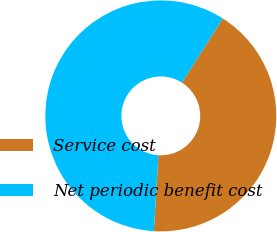Convert chart to OTSL. <chart><loc_0><loc_0><loc_500><loc_500><pie_chart><fcel>Service cost<fcel>Net periodic benefit cost<nl><fcel>41.95%<fcel>58.05%<nl></chart> 